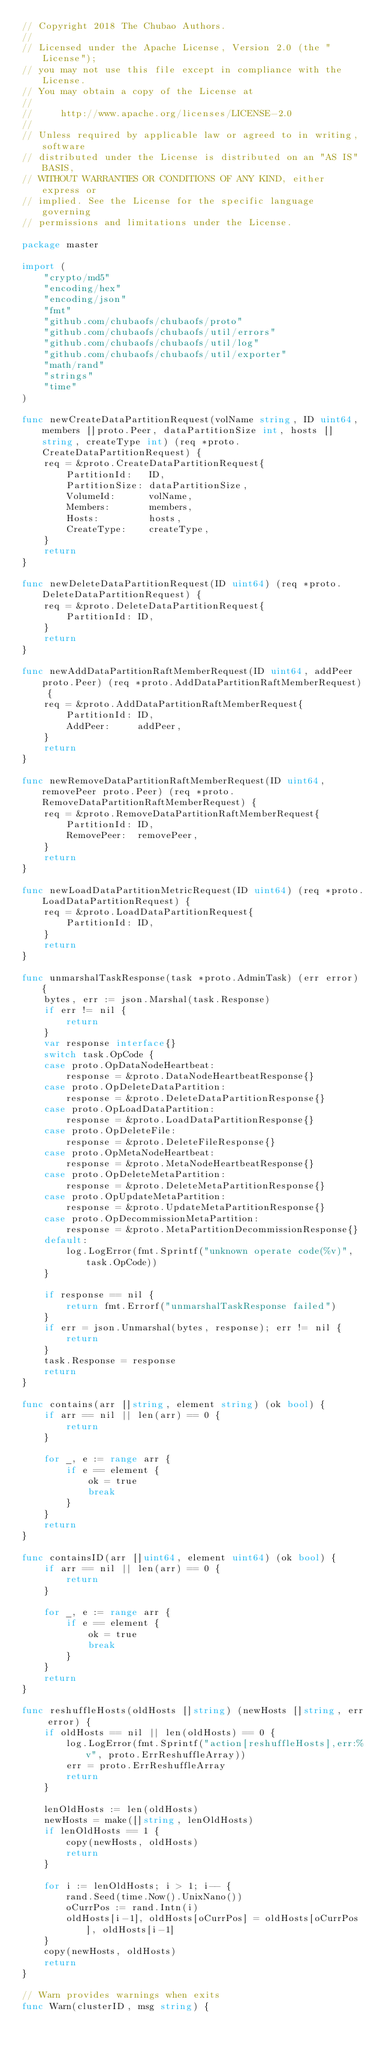<code> <loc_0><loc_0><loc_500><loc_500><_Go_>// Copyright 2018 The Chubao Authors.
//
// Licensed under the Apache License, Version 2.0 (the "License");
// you may not use this file except in compliance with the License.
// You may obtain a copy of the License at
//
//     http://www.apache.org/licenses/LICENSE-2.0
//
// Unless required by applicable law or agreed to in writing, software
// distributed under the License is distributed on an "AS IS" BASIS,
// WITHOUT WARRANTIES OR CONDITIONS OF ANY KIND, either express or
// implied. See the License for the specific language governing
// permissions and limitations under the License.

package master

import (
	"crypto/md5"
	"encoding/hex"
	"encoding/json"
	"fmt"
	"github.com/chubaofs/chubaofs/proto"
	"github.com/chubaofs/chubaofs/util/errors"
	"github.com/chubaofs/chubaofs/util/log"
	"github.com/chubaofs/chubaofs/util/exporter"
	"math/rand"
	"strings"
	"time"
)

func newCreateDataPartitionRequest(volName string, ID uint64, members []proto.Peer, dataPartitionSize int, hosts []string, createType int) (req *proto.CreateDataPartitionRequest) {
	req = &proto.CreateDataPartitionRequest{
		PartitionId:   ID,
		PartitionSize: dataPartitionSize,
		VolumeId:      volName,
		Members:       members,
		Hosts:         hosts,
		CreateType:    createType,
	}
	return
}

func newDeleteDataPartitionRequest(ID uint64) (req *proto.DeleteDataPartitionRequest) {
	req = &proto.DeleteDataPartitionRequest{
		PartitionId: ID,
	}
	return
}

func newAddDataPartitionRaftMemberRequest(ID uint64, addPeer proto.Peer) (req *proto.AddDataPartitionRaftMemberRequest) {
	req = &proto.AddDataPartitionRaftMemberRequest{
		PartitionId: ID,
		AddPeer:     addPeer,
	}
	return
}

func newRemoveDataPartitionRaftMemberRequest(ID uint64, removePeer proto.Peer) (req *proto.RemoveDataPartitionRaftMemberRequest) {
	req = &proto.RemoveDataPartitionRaftMemberRequest{
		PartitionId: ID,
		RemovePeer:  removePeer,
	}
	return
}

func newLoadDataPartitionMetricRequest(ID uint64) (req *proto.LoadDataPartitionRequest) {
	req = &proto.LoadDataPartitionRequest{
		PartitionId: ID,
	}
	return
}

func unmarshalTaskResponse(task *proto.AdminTask) (err error) {
	bytes, err := json.Marshal(task.Response)
	if err != nil {
		return
	}
	var response interface{}
	switch task.OpCode {
	case proto.OpDataNodeHeartbeat:
		response = &proto.DataNodeHeartbeatResponse{}
	case proto.OpDeleteDataPartition:
		response = &proto.DeleteDataPartitionResponse{}
	case proto.OpLoadDataPartition:
		response = &proto.LoadDataPartitionResponse{}
	case proto.OpDeleteFile:
		response = &proto.DeleteFileResponse{}
	case proto.OpMetaNodeHeartbeat:
		response = &proto.MetaNodeHeartbeatResponse{}
	case proto.OpDeleteMetaPartition:
		response = &proto.DeleteMetaPartitionResponse{}
	case proto.OpUpdateMetaPartition:
		response = &proto.UpdateMetaPartitionResponse{}
	case proto.OpDecommissionMetaPartition:
		response = &proto.MetaPartitionDecommissionResponse{}
	default:
		log.LogError(fmt.Sprintf("unknown operate code(%v)", task.OpCode))
	}

	if response == nil {
		return fmt.Errorf("unmarshalTaskResponse failed")
	}
	if err = json.Unmarshal(bytes, response); err != nil {
		return
	}
	task.Response = response
	return
}

func contains(arr []string, element string) (ok bool) {
	if arr == nil || len(arr) == 0 {
		return
	}

	for _, e := range arr {
		if e == element {
			ok = true
			break
		}
	}
	return
}

func containsID(arr []uint64, element uint64) (ok bool) {
	if arr == nil || len(arr) == 0 {
		return
	}

	for _, e := range arr {
		if e == element {
			ok = true
			break
		}
	}
	return
}

func reshuffleHosts(oldHosts []string) (newHosts []string, err error) {
	if oldHosts == nil || len(oldHosts) == 0 {
		log.LogError(fmt.Sprintf("action[reshuffleHosts],err:%v", proto.ErrReshuffleArray))
		err = proto.ErrReshuffleArray
		return
	}

	lenOldHosts := len(oldHosts)
	newHosts = make([]string, lenOldHosts)
	if lenOldHosts == 1 {
		copy(newHosts, oldHosts)
		return
	}

	for i := lenOldHosts; i > 1; i-- {
		rand.Seed(time.Now().UnixNano())
		oCurrPos := rand.Intn(i)
		oldHosts[i-1], oldHosts[oCurrPos] = oldHosts[oCurrPos], oldHosts[i-1]
	}
	copy(newHosts, oldHosts)
	return
}

// Warn provides warnings when exits
func Warn(clusterID, msg string) {</code> 